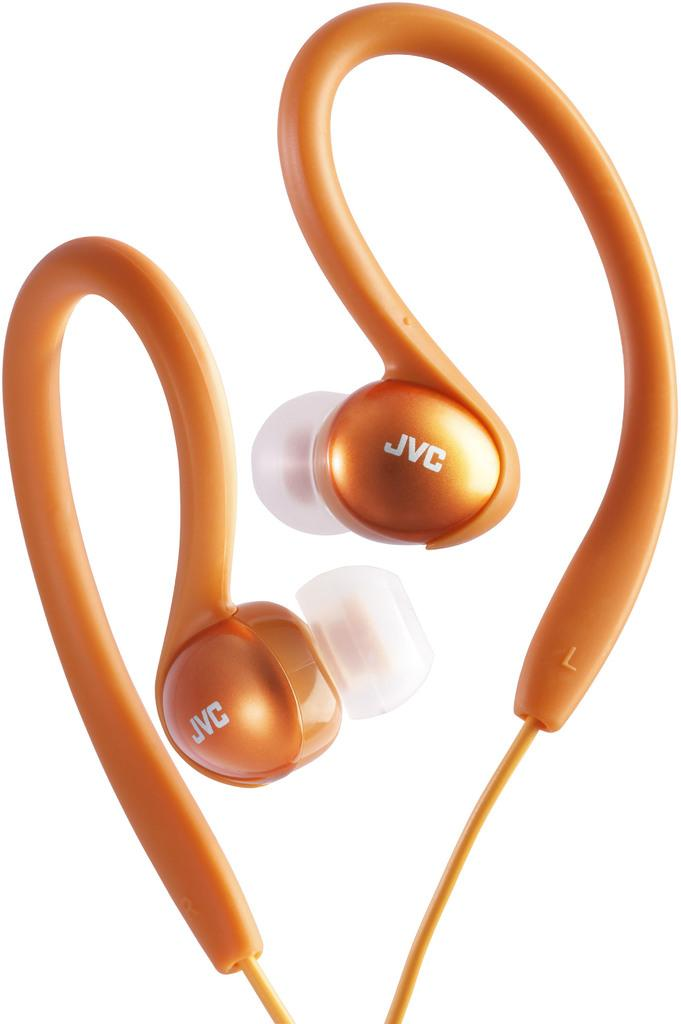<image>
Write a terse but informative summary of the picture. Orange JVC over the ear headphones are on display. 